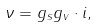Convert formula to latex. <formula><loc_0><loc_0><loc_500><loc_500>\nu = g _ { s } g _ { v } \cdot i ,</formula> 